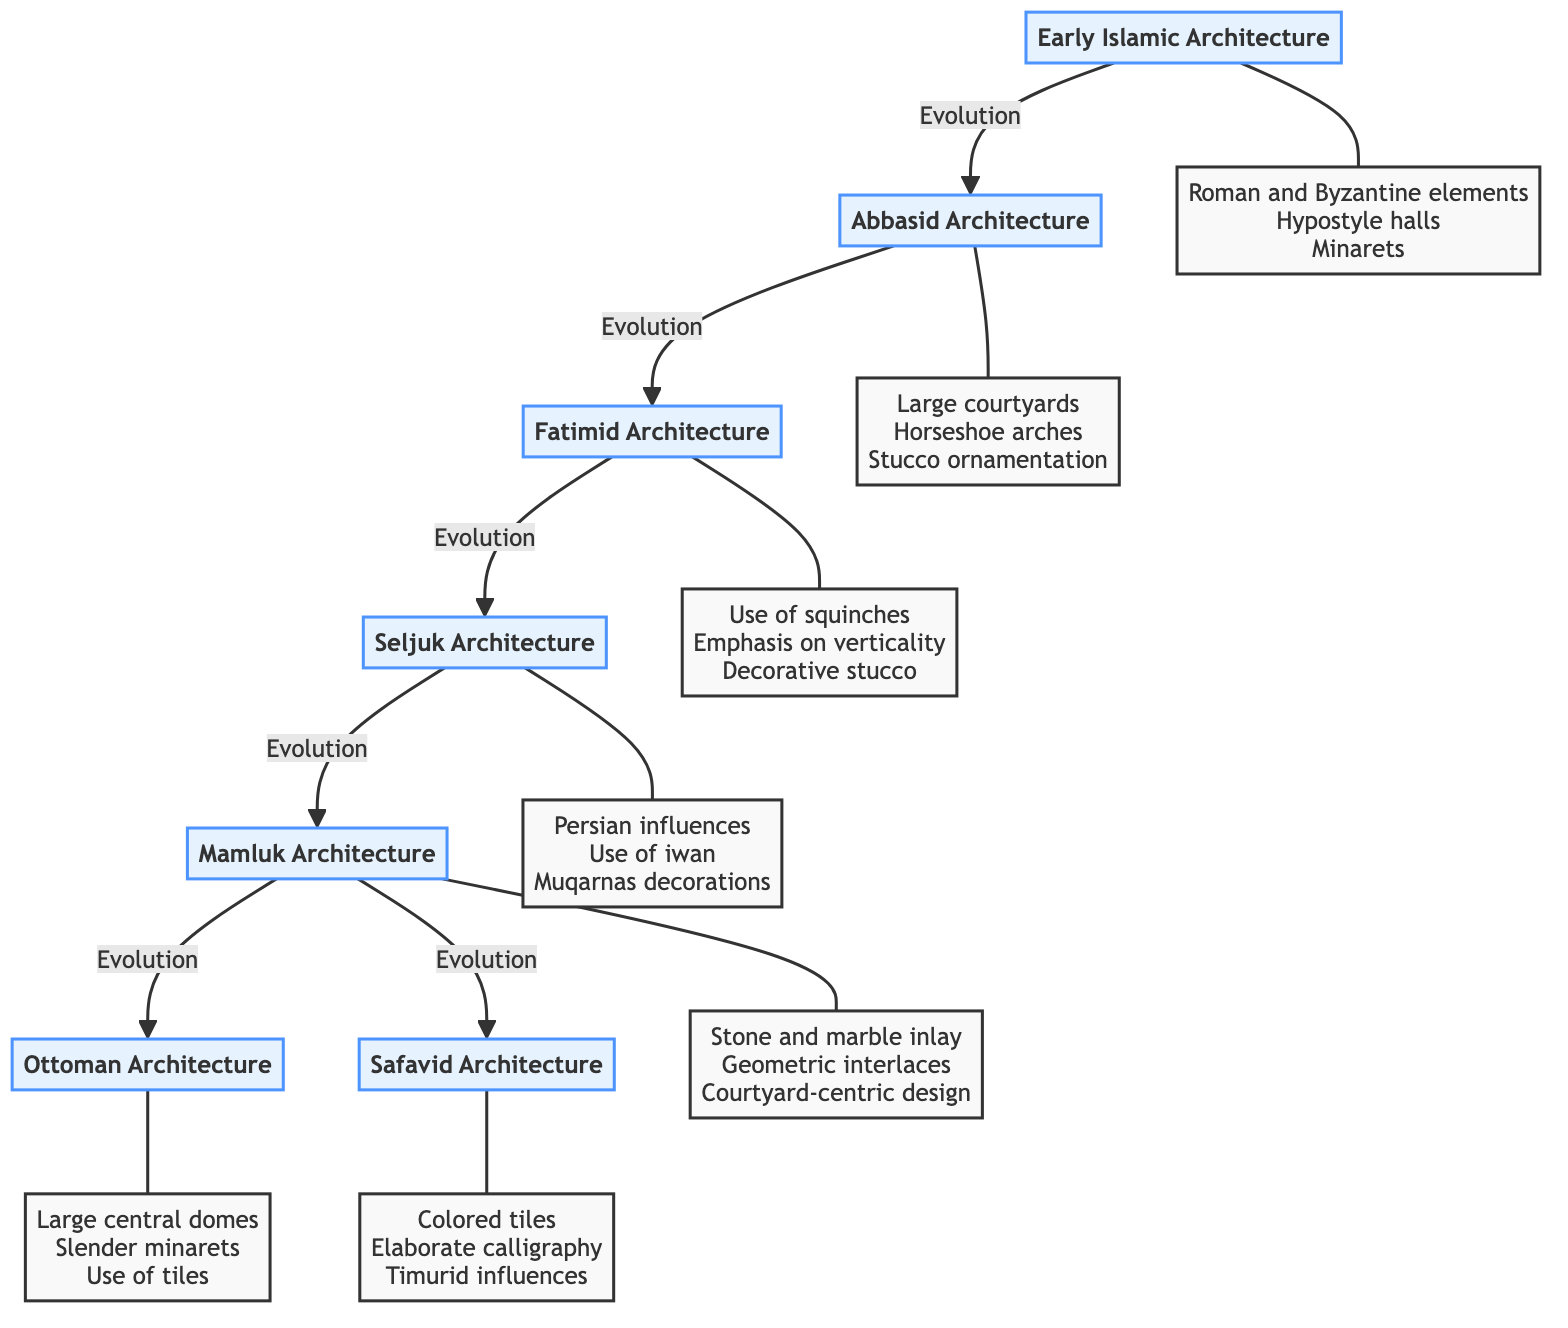What is the first architectural style in the diagram? The diagram starts with "Early Islamic Architecture" as the first node, indicating it is the initial architectural style in the sequence of evolution.
Answer: Early Islamic Architecture How many architectural styles are shown in the diagram? By counting the nodes listed in the diagram, there are a total of seven different architectural styles represented.
Answer: 7 What key feature is associated with Mamluk Architecture? The Mamluk Architecture node indicates "Elaborate stone and marble inlay," highlighting a significant key feature of this style.
Answer: Elaborate stone and marble inlay Which architectural style uses squinches? According to the diagram, "Fatimid Architecture" is the style that is associated with the use of squinches, as noted in its descriptive content.
Answer: Fatimid Architecture What is the evolutionary relationship between Abbasid and Fatimid architecture? The diagram shows a direct evolution from "Abbasid Architecture" to "Fatimid Architecture," meaning Fatimid architecture developed after Abbasid architecture.
Answer: Evolution Which architectural style features large central domes? The section for the "Ottoman Architecture" notes the use of "Large central domes," making it clear that this style is characterized by such features.
Answer: Ottoman Architecture What type of decoration is highlighted in Seljuk Architecture? The content for "Seljuk Architecture" mentions "Muqarnas decorations," indicating the type of decoration that is prominent in this architectural style.
Answer: Muqarnas decorations What common feature delineates both Mamluk and Ottoman architectures? Analyzing the nodes, both architectures showcase intricate designs and detailed ornamentation, although the Mamluk emphasizes geometric interlaces while the Ottoman uses tiles. Commonly, both have courtyard-centric designs.
Answer: Courtyard-centric design Which architectural style is influenced by Persian architecture? The "Seljuk Architecture" node indicates "Persian influences," confirming its connection to Persian styles in its design elements.
Answer: Seljuk Architecture 